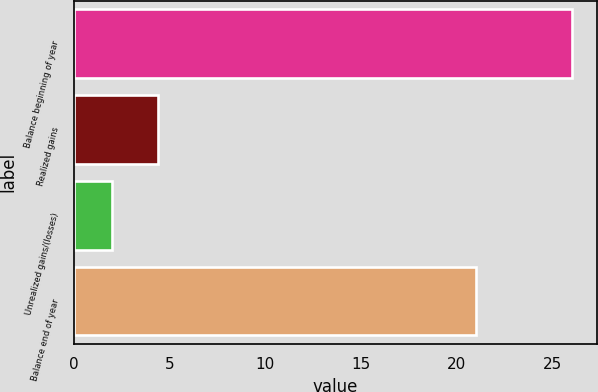Convert chart to OTSL. <chart><loc_0><loc_0><loc_500><loc_500><bar_chart><fcel>Balance beginning of year<fcel>Realized gains<fcel>Unrealized gains/(losses)<fcel>Balance end of year<nl><fcel>26<fcel>4.4<fcel>2<fcel>21<nl></chart> 